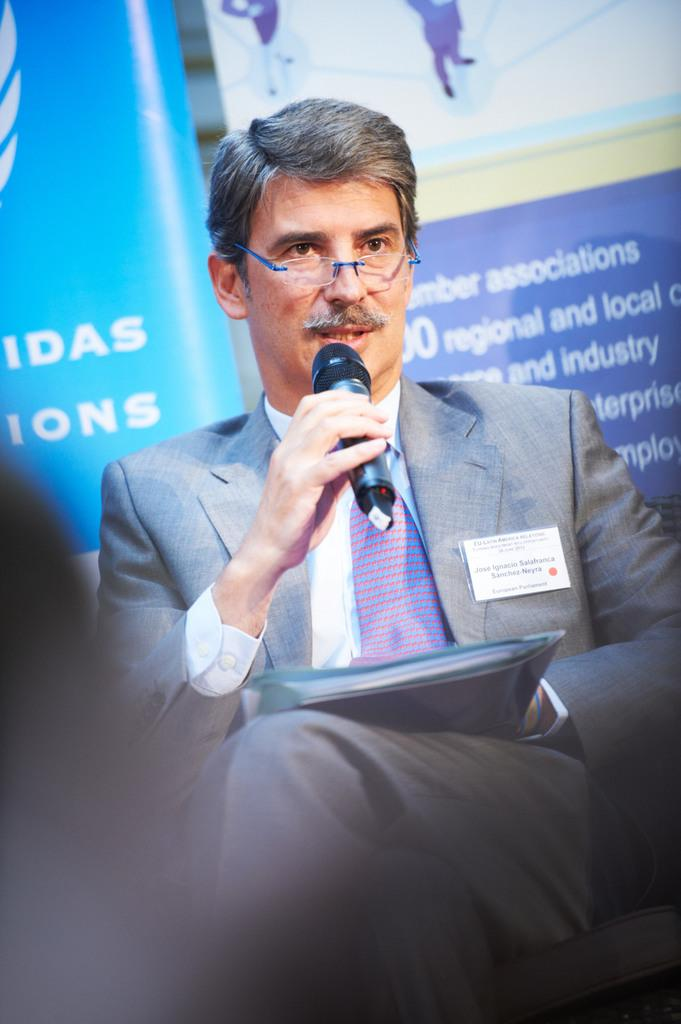What is the person in the image doing? The person is sitting on a chair and talking in front of a microphone. What might the person be holding in their hand? The person is holding a file. What can be seen behind the person? There are banners visible behind the person. What type of vessel can be seen floating in the background of the image? There is no vessel present in the image; it features a person sitting on a chair, holding a file, and talking in front of a microphone with banners visible behind them. 